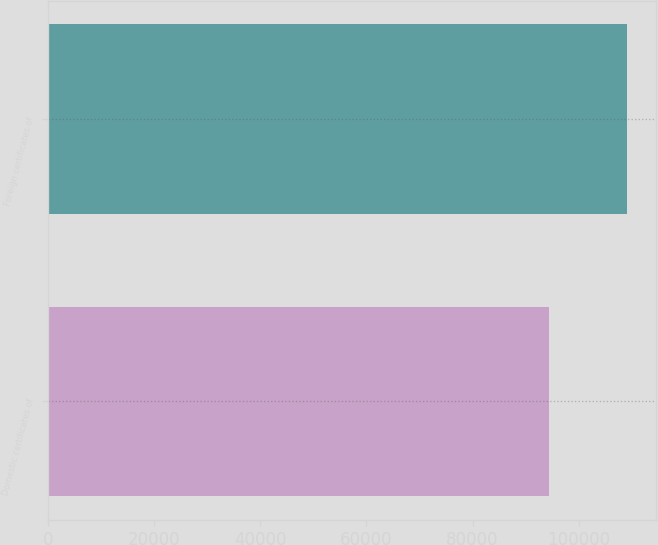Convert chart to OTSL. <chart><loc_0><loc_0><loc_500><loc_500><bar_chart><fcel>Domestic certificates of<fcel>Foreign certificates of<nl><fcel>94440<fcel>109121<nl></chart> 